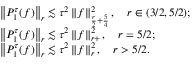<formula> <loc_0><loc_0><loc_500><loc_500>\begin{array} { r l } & { \left \| P _ { 1 } ^ { \tau } ( f ) \right \| _ { r } \lesssim \tau ^ { 2 } \left \| f \right \| _ { \frac { r } { 2 } + \frac { 5 } { 4 } } ^ { 2 } , \quad r \in ( 3 / 2 , 5 / 2 ) ; } \\ & { \left \| P _ { 1 } ^ { \tau } ( f ) \right \| _ { r } \lesssim \tau ^ { 2 } \left \| f \right \| _ { r + } ^ { 2 } , \quad r = 5 / 2 ; } \\ & { \left \| P _ { 1 } ^ { \tau } ( f ) \right \| _ { r } \lesssim \tau ^ { 2 } \left \| f \right \| _ { r } ^ { 2 } , \quad r > 5 / 2 . } \end{array}</formula> 